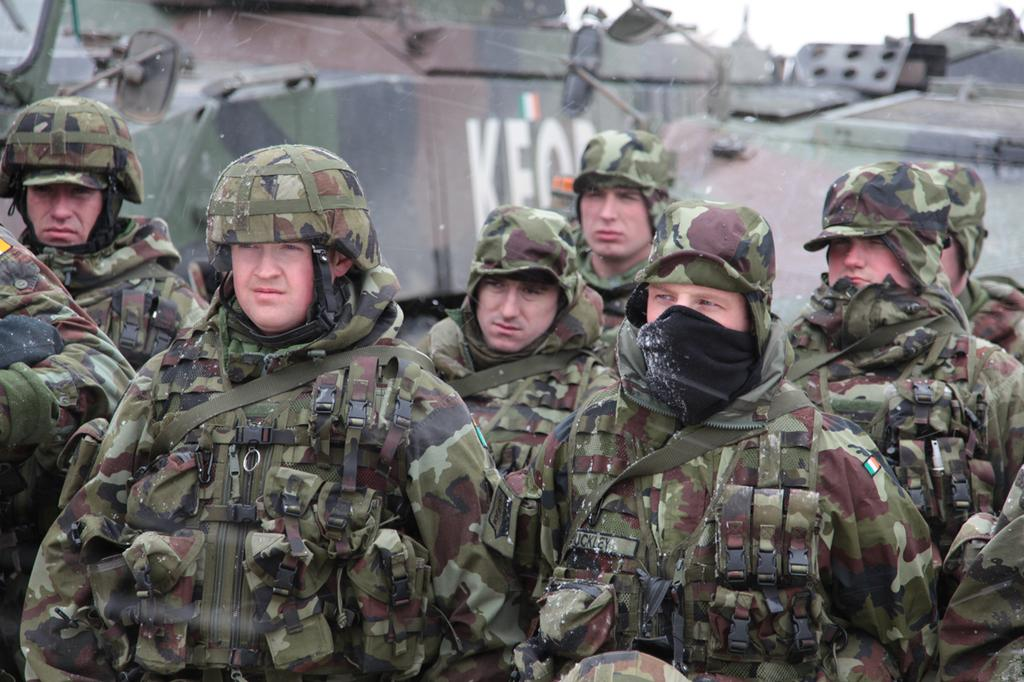What is happening in the middle of the image? There are people standing in the middle of the image. What are the people doing? The people are watching something. What can be seen behind the people? There are vehicles behind the people. What part of the sky is visible in the image? The sky is visible in the top right side of the image. What type of basketball game is being played in the image? There is no basketball game present in the image. What kind of test is the person taking in the image? There is no person taking a test in the image. 